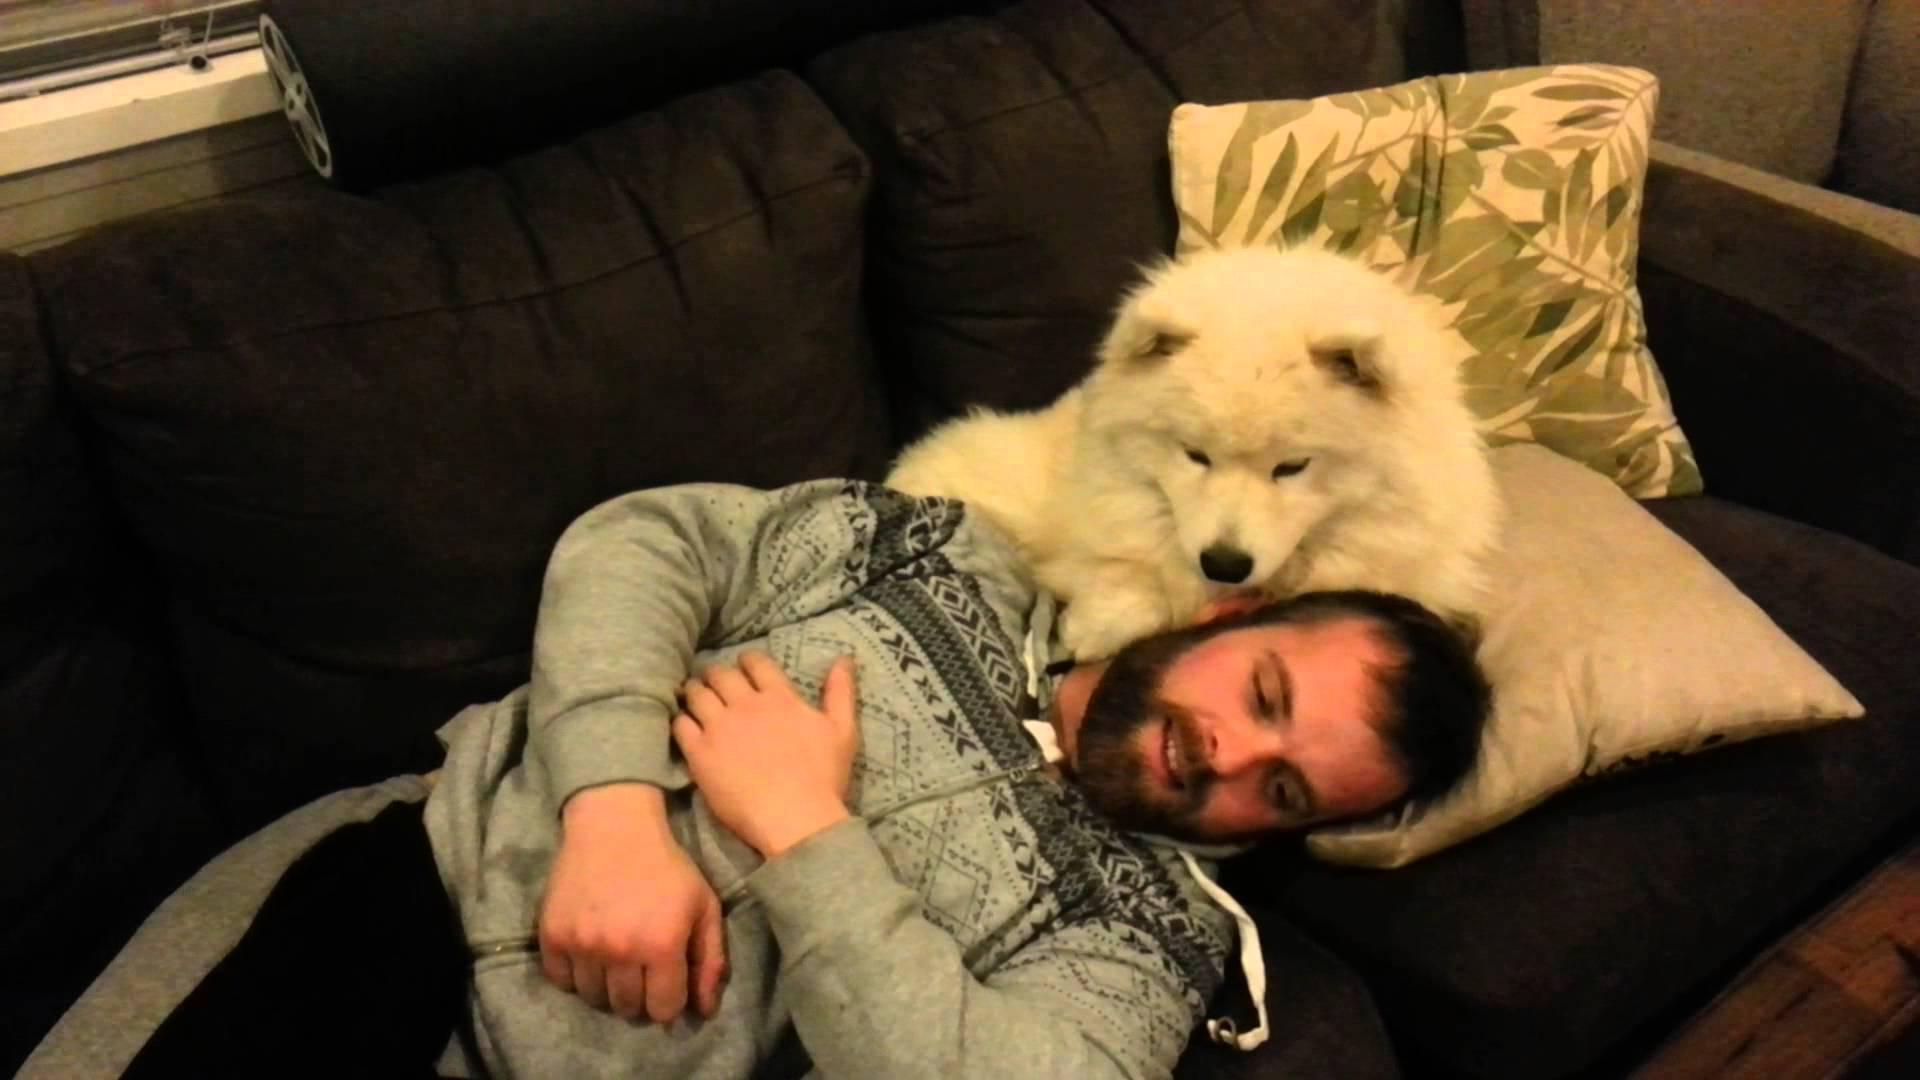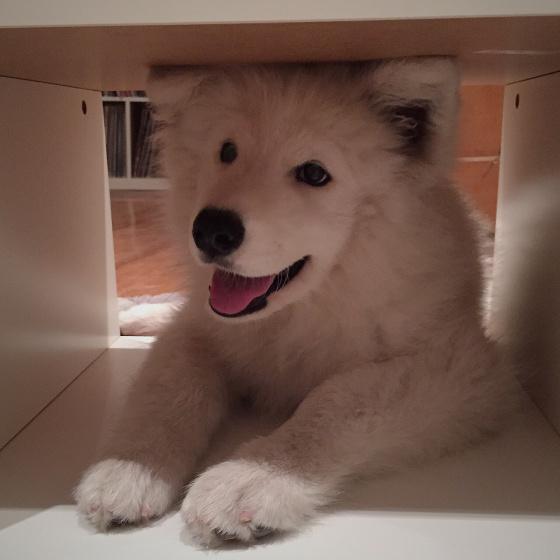The first image is the image on the left, the second image is the image on the right. For the images shown, is this caption "The dog in the image on the right is on a wooden floor." true? Answer yes or no. No. The first image is the image on the left, the second image is the image on the right. Analyze the images presented: Is the assertion "Each image contains exactly one reclining white dog." valid? Answer yes or no. Yes. 